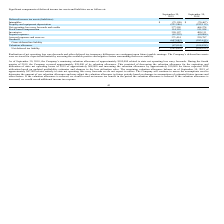According to Clearfield's financial document, What is the approximate amount of valuation allowance that the Company has reversed in the forth quarter of 2019? According to the financial document, $58,000. The relevant text states: "uarter of 2019, the Company reversed approximately $58,000 of its valuation allowance. This consisted of decreasing the valuation allowance for the expiration..." Also, What actions will the Company take when the valuation allowance is increased? record additional income tax expense. The document states: "If the valuation allowance is increased, we would record additional income tax expense...." Also, What is the gross deferred tax liability as of September 30, 2018? According to the financial document, 77. The relevant text states: "Net operating loss carry forwards and credits 377,505 464,274..." Also, can you calculate: What is the percentage change in the net operating loss carry forwards and credits from 2018 to 2019? To answer this question, I need to perform calculations using the financial data. The calculation is: (377,505-464,274)/464,274, which equals -18.69 (percentage). This is based on the information: "operating loss carry forwards and credits 377,505 464,274 Net operating loss carry forwards and credits 377,505 464,274..." The key data points involved are: 377,505, 464,274. Also, can you calculate: What is the percentage change in gross deferred tax liability from 2018 to 2019? To answer this question, I need to perform calculations using the financial data. The calculation is: (54,676-77)/77, which equals 70907.79 (percentage). This is based on the information: "Gross deferred tax liability (54,676) (77) Gross deferred tax liability (54,676) (77)..." The key data points involved are: 54,676, 77. Also, can you calculate: What is the percentage change in the net deferred tax liability from 2018 to 2019? To answer this question, I need to perform calculations using the financial data. The calculation is: (101,690-104,935)/104,935, which equals -3.09 (percentage). This is based on the information: "Net deferred tax liability $ (101,690) $ (104,935) Net deferred tax liability $ (101,690) $ (104,935)..." The key data points involved are: 101,690, 104,935. 